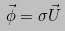Convert formula to latex. <formula><loc_0><loc_0><loc_500><loc_500>\vec { \phi } = \sigma \vec { U }</formula> 